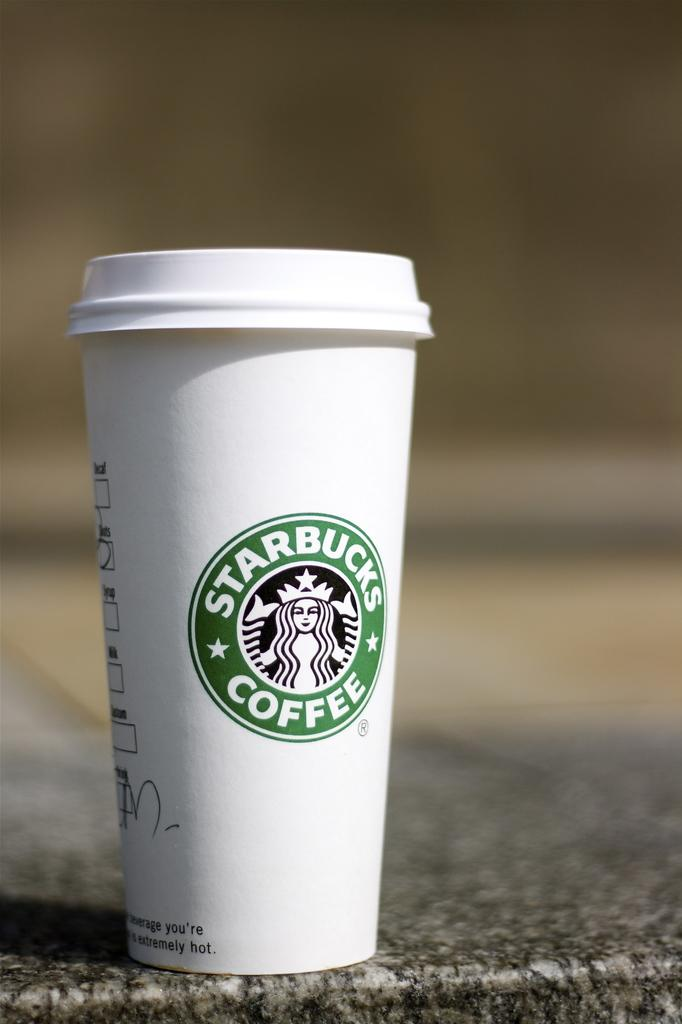What type of container is in the image? There is a white tumbler with a cap in the image. Is there any branding or logo on the tumbler? Yes, the tumbler has a logo on it. Where is the tumbler placed in the image? The tumbler is placed on a stone table. What type of pain is the person experiencing in the image? There is no person present in the image, and therefore no indication of any pain being experienced. 